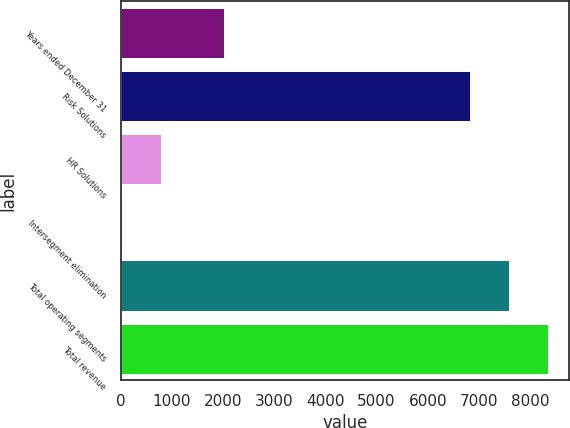Convert chart to OTSL. <chart><loc_0><loc_0><loc_500><loc_500><bar_chart><fcel>Years ended December 31<fcel>Risk Solutions<fcel>HR Solutions<fcel>Intersegment elimination<fcel>Total operating segments<fcel>Total revenue<nl><fcel>2009<fcel>6835<fcel>782.9<fcel>26<fcel>7591.9<fcel>8348.8<nl></chart> 